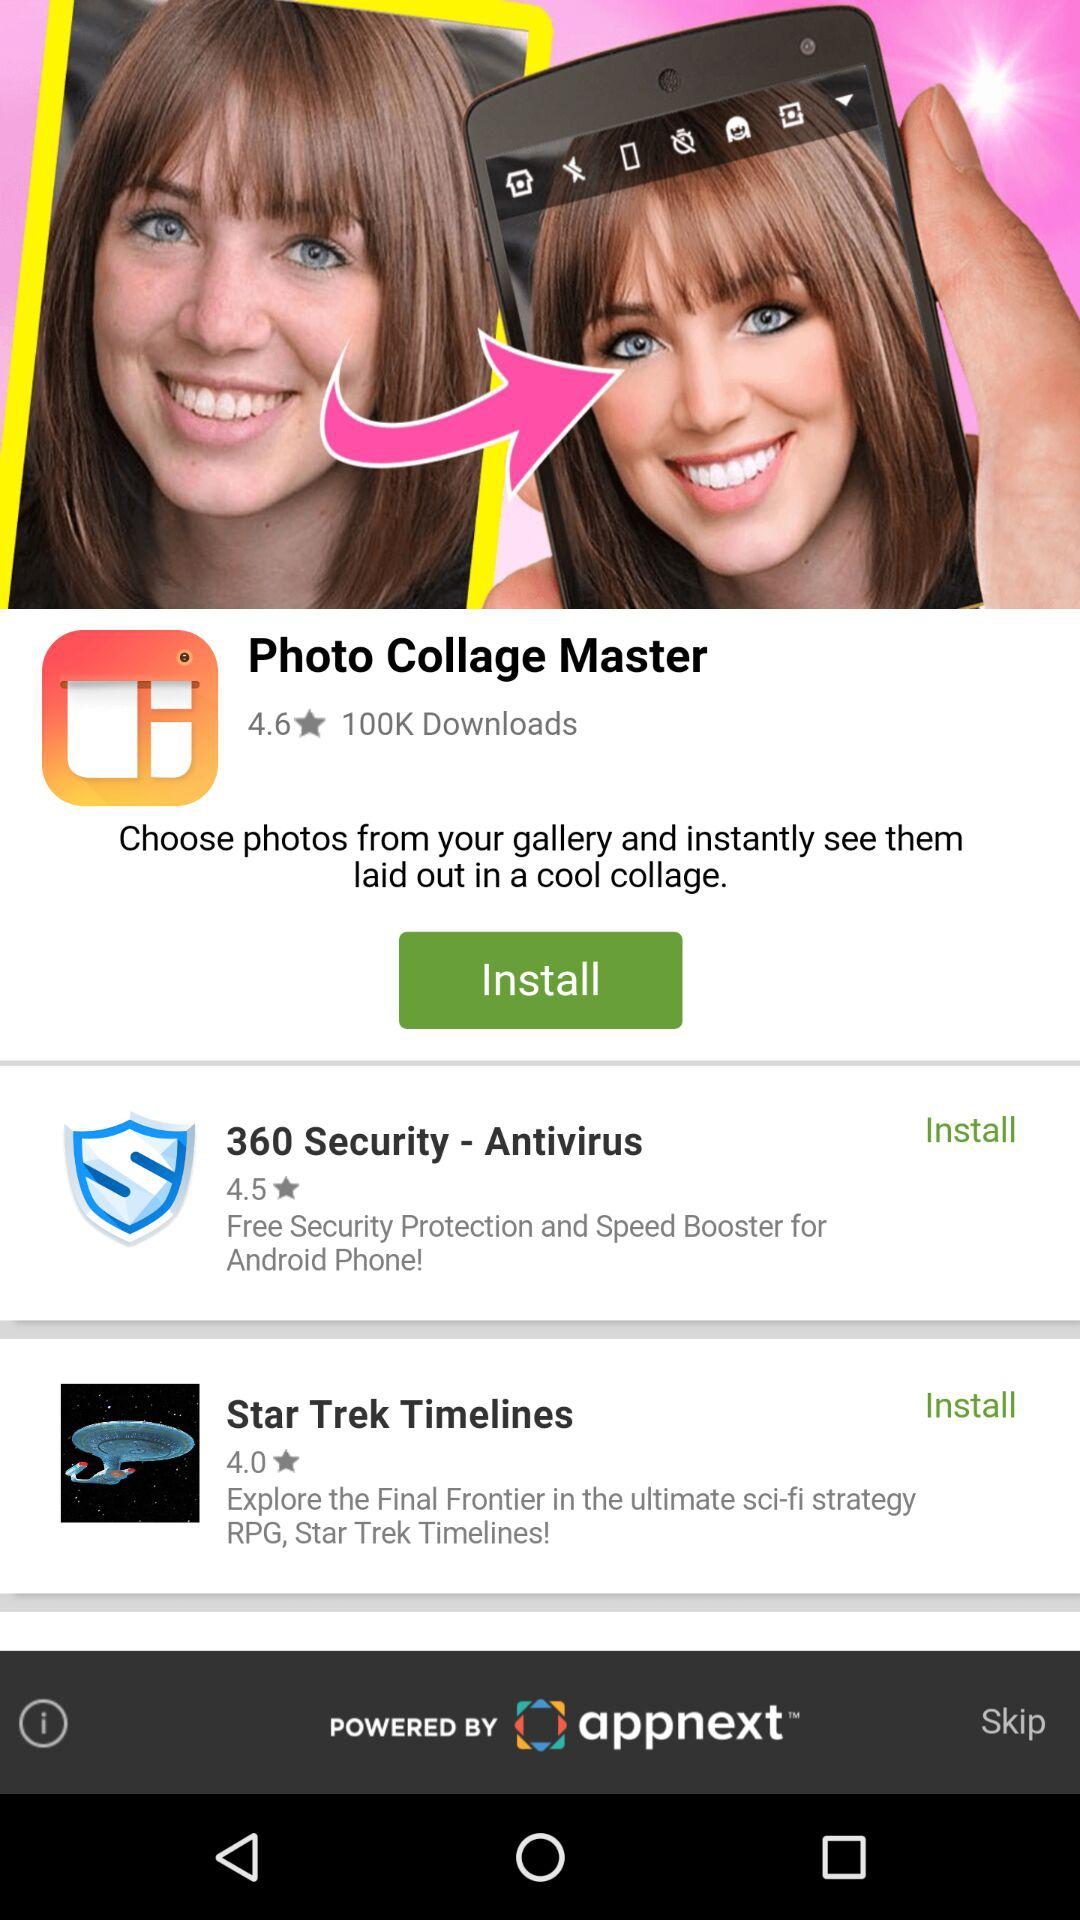What is the star rating of Photo Collage Master? The star rating is 4.6. 